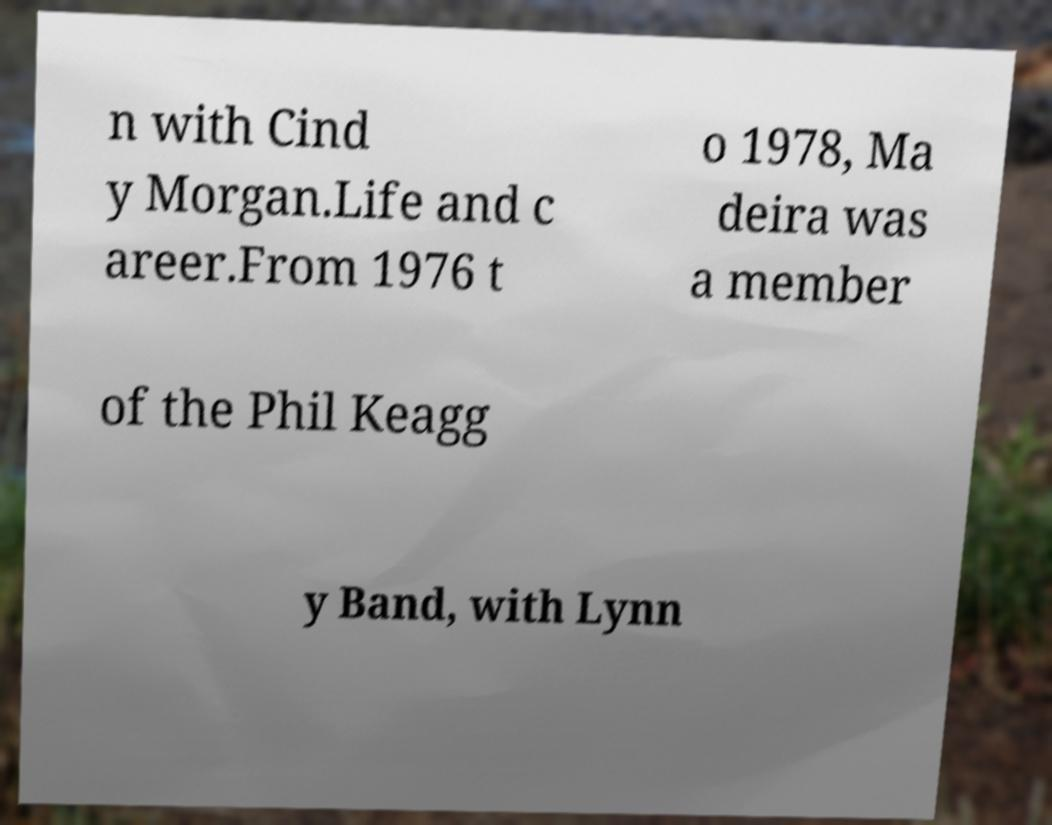What messages or text are displayed in this image? I need them in a readable, typed format. n with Cind y Morgan.Life and c areer.From 1976 t o 1978, Ma deira was a member of the Phil Keagg y Band, with Lynn 